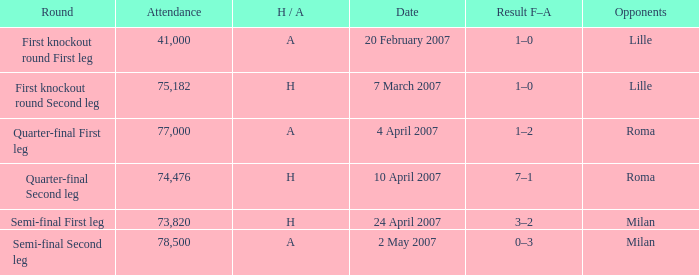Which round has an Opponent of lille, and a H / A of h? First knockout round Second leg. 